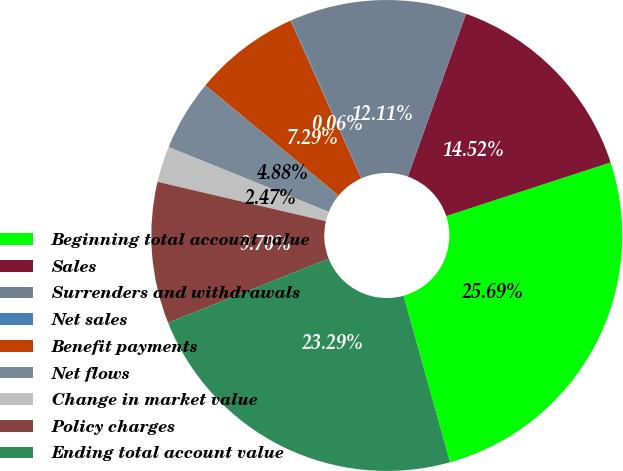Convert chart. <chart><loc_0><loc_0><loc_500><loc_500><pie_chart><fcel>Beginning total account value<fcel>Sales<fcel>Surrenders and withdrawals<fcel>Net sales<fcel>Benefit payments<fcel>Net flows<fcel>Change in market value<fcel>Policy charges<fcel>Ending total account value<nl><fcel>25.7%<fcel>14.52%<fcel>12.11%<fcel>0.06%<fcel>7.29%<fcel>4.88%<fcel>2.47%<fcel>9.7%<fcel>23.29%<nl></chart> 